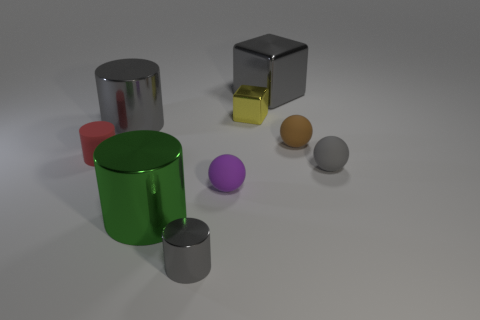The tiny gray thing that is behind the small gray object that is on the left side of the big metal cube is made of what material?
Offer a very short reply. Rubber. What color is the other big cylinder that is made of the same material as the large gray cylinder?
Make the answer very short. Green. There is a large metallic thing that is the same color as the large block; what is its shape?
Your answer should be very brief. Cylinder. There is a gray metallic thing in front of the purple rubber thing; is its size the same as the matte thing left of the large gray cylinder?
Ensure brevity in your answer.  Yes. How many cubes are either metal things or tiny red matte objects?
Offer a very short reply. 2. Is the cube behind the yellow cube made of the same material as the red cylinder?
Offer a terse response. No. How many other things are there of the same size as the gray rubber ball?
Your answer should be compact. 5. What number of small objects are yellow objects or red cylinders?
Keep it short and to the point. 2. Is the small cube the same color as the small metallic cylinder?
Offer a terse response. No. Is the number of gray rubber balls that are to the left of the tiny brown object greater than the number of large gray things behind the yellow metal block?
Your answer should be compact. No. 